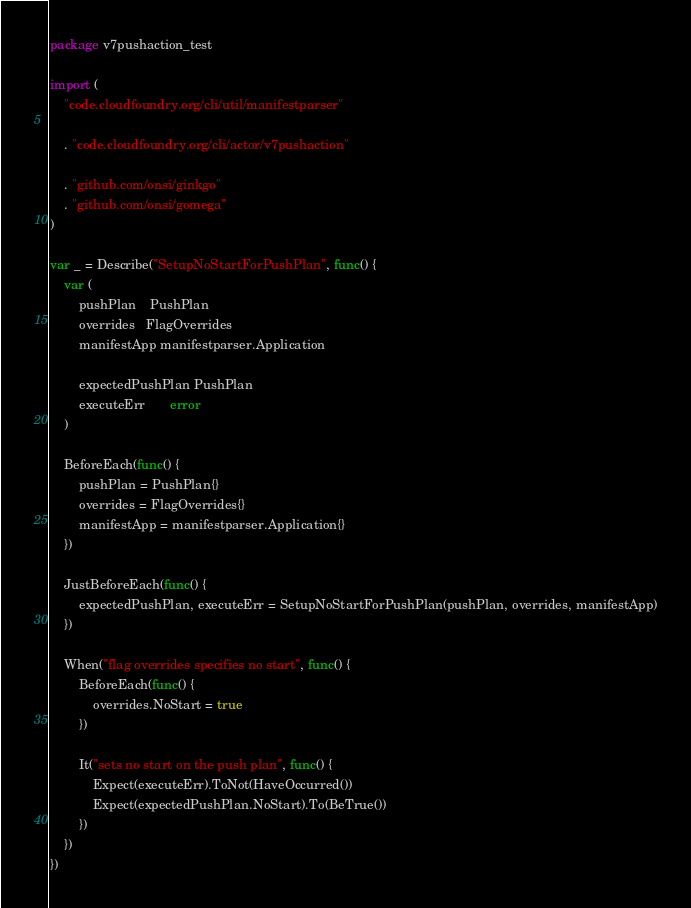Convert code to text. <code><loc_0><loc_0><loc_500><loc_500><_Go_>package v7pushaction_test

import (
	"code.cloudfoundry.org/cli/util/manifestparser"

	. "code.cloudfoundry.org/cli/actor/v7pushaction"

	. "github.com/onsi/ginkgo"
	. "github.com/onsi/gomega"
)

var _ = Describe("SetupNoStartForPushPlan", func() {
	var (
		pushPlan    PushPlan
		overrides   FlagOverrides
		manifestApp manifestparser.Application

		expectedPushPlan PushPlan
		executeErr       error
	)

	BeforeEach(func() {
		pushPlan = PushPlan{}
		overrides = FlagOverrides{}
		manifestApp = manifestparser.Application{}
	})

	JustBeforeEach(func() {
		expectedPushPlan, executeErr = SetupNoStartForPushPlan(pushPlan, overrides, manifestApp)
	})

	When("flag overrides specifies no start", func() {
		BeforeEach(func() {
			overrides.NoStart = true
		})

		It("sets no start on the push plan", func() {
			Expect(executeErr).ToNot(HaveOccurred())
			Expect(expectedPushPlan.NoStart).To(BeTrue())
		})
	})
})
</code> 